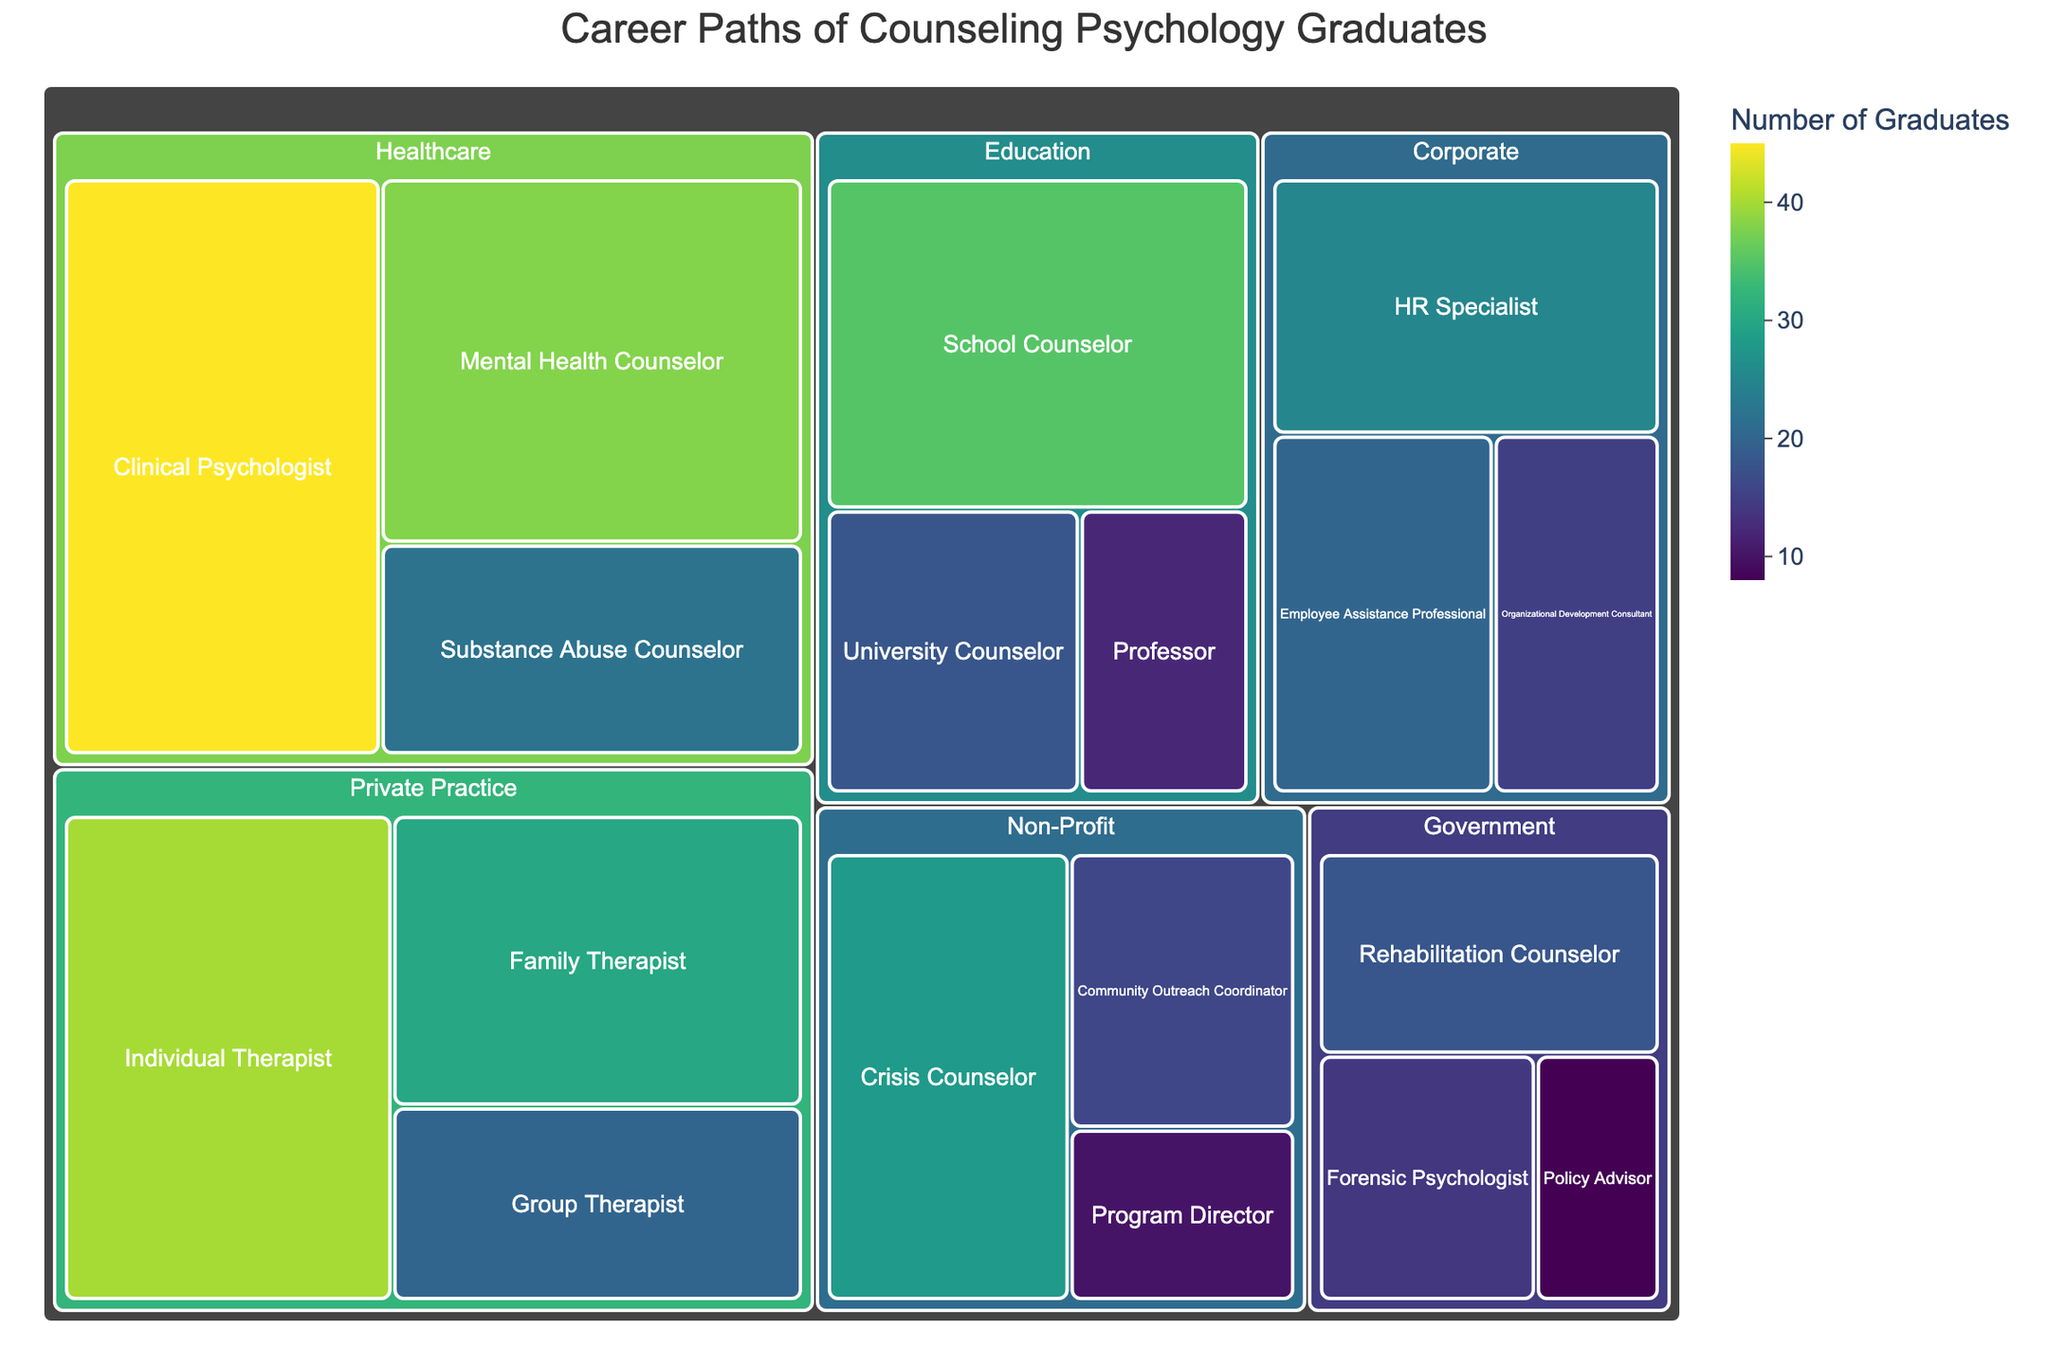What's the title of the treemap? The title is usually presented at the top of the figure. Read the text at the top to find the title.
Answer: Career Paths of Counseling Psychology Graduates Which sector has the highest number of graduates? Identify the sector with the largest area or the deepest color in the treemap, indicating the highest count.
Answer: Healthcare How many graduates chose the role of Policy Advisor? Locate the segment labeled as Policy Advisor within the Government sector and check the number of graduates shown.
Answer: 8 What is the combined number of graduates in the Education sector? Sum the figures for all roles in the Education sector (35 + 18 + 12).
Answer: 65 Which sector has more graduates, Non-Profit or Private Practice? Compare the total graduates in Non-Profit (28 + 16 + 10) with those in Private Practice (40 + 30 + 20).
Answer: Private Practice Is there a role within the Corporate sector that has fewer than 20 graduates? Inspect each role in the Corporate sector to see if any have a count smaller than 20.
Answer: Yes (Organizational Development Consultant has 15) What's the difference in the number of graduates between Individual Therapist and Mental Health Counselor? Subtract the number of graduates for Mental Health Counselor (38) from those for Individual Therapist (40).
Answer: 2 Which role has the highest number of graduates within the Healthcare sector? Find out which role in Healthcare has the largest figure.
Answer: Clinical Psychologist What is the distribution of graduates among the different roles in the Government sector? List each role in Government and its corresponding number of graduates: Rehabilitation Counselor (18), Forensic Psychologist (14), Policy Advisor (8).
Answer: Rehabilitation Counselor 18, Forensic Psychologist 14, Policy Advisor 8 Which sector appears most diverse in terms of the number of different job roles? Count the number of unique job roles in each sector and identify the sector with the highest count.
Answer: Healthcare 